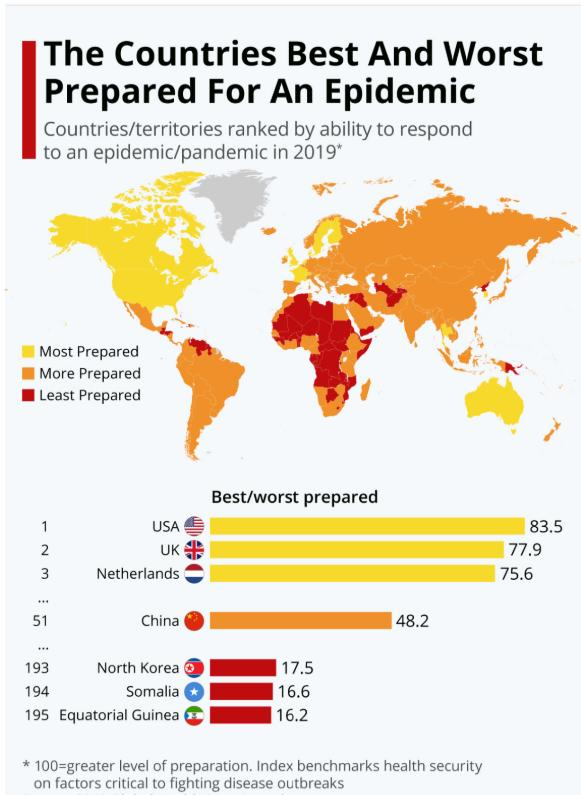Mention a couple of crucial points in this snapshot. The Netherlands was the country that was most prepared for a pandemic in 2019, other than the United States and the United Kingdom. Somalia was the country that was least prepared for a pandemic in 2019, except for North Korea and Equatorial Guinea. In 2019, China was more prepared for a pandemic compared to the other countries given. 